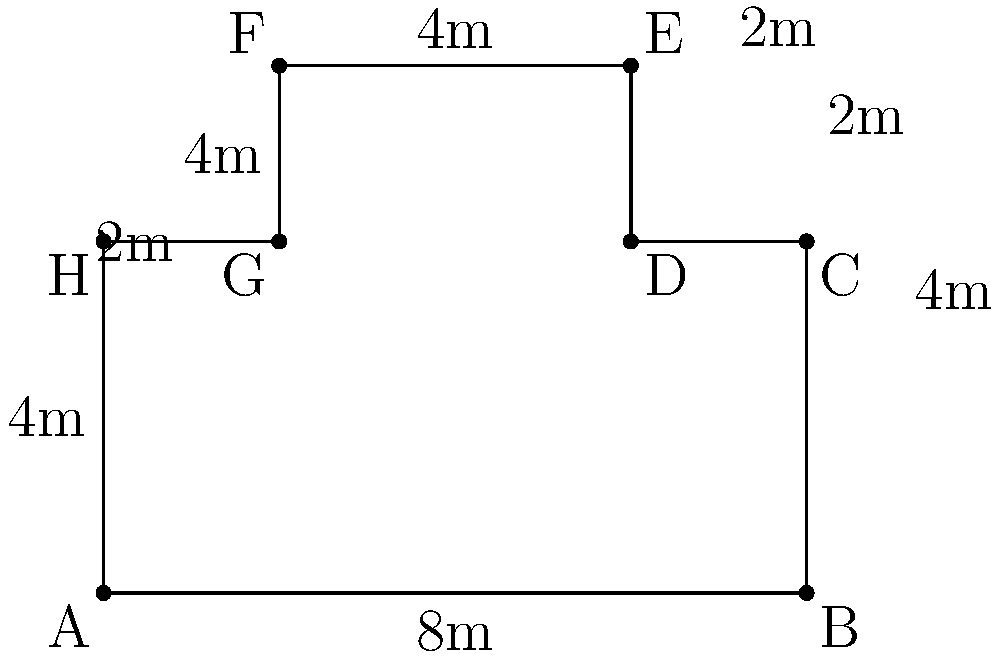As a police officer investigating a crime scene, you need to calculate the perimeter of the irregular-shaped area shown in the diagram. All measurements are in meters. What is the total perimeter of the crime scene? To calculate the perimeter of the irregular-shaped crime scene, we need to sum up the lengths of all sides:

1. Side AB: $8$ m
2. Side BC: $4$ m
3. Side CD: $2$ m
4. Side DE: $2$ m
5. Side EF: $4$ m
6. Side FG: $4$ m
7. Side GH: $2$ m
8. Side HA: $4$ m

Total perimeter = $8 + 4 + 2 + 2 + 4 + 4 + 2 + 4 = 30$ m

Therefore, the total perimeter of the crime scene is 30 meters.
Answer: $30$ m 